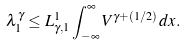<formula> <loc_0><loc_0><loc_500><loc_500>\lambda _ { 1 } ^ { \gamma } \leq L _ { \gamma , 1 } ^ { 1 } \int _ { - \infty } ^ { \infty } V ^ { \gamma + ( 1 / 2 ) } \, d x .</formula> 